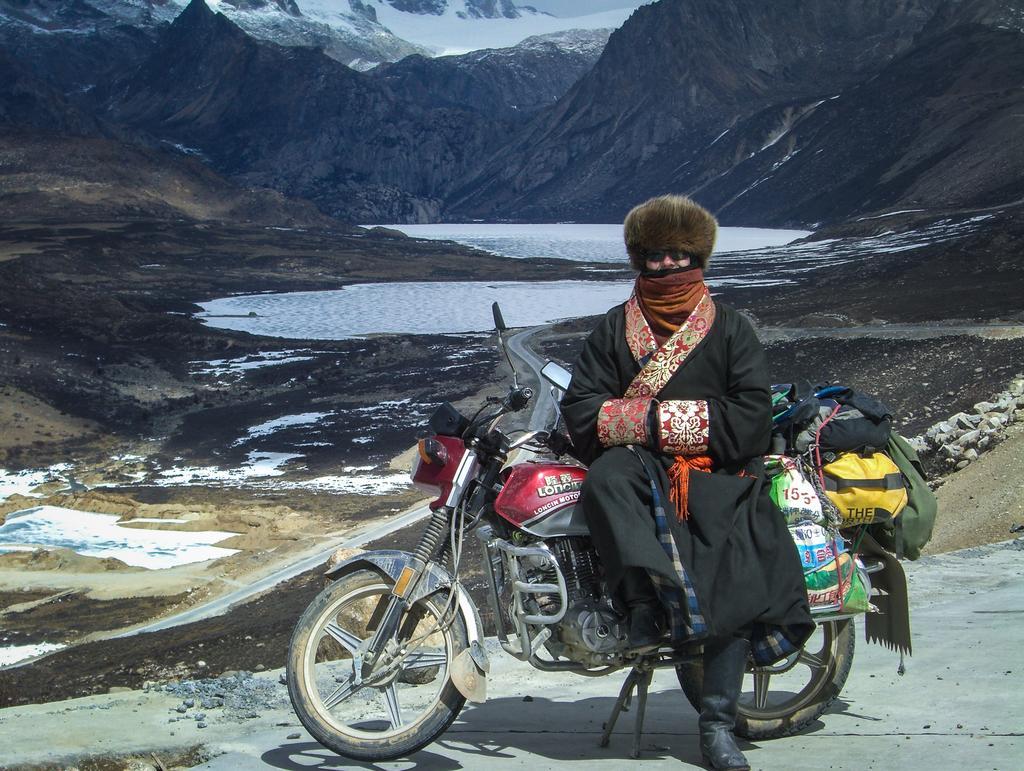How would you summarize this image in a sentence or two? This picture is clicked outside the city. In the middle of the picture, we see a person in black dress is wearing scarf around his neck, even wearing goggles and cap and he is is sitting on bike. On bike, we see many bags and covers tied to it. Behind him, we see water. Behind water or lake, we see mountains which are covered with snow. 